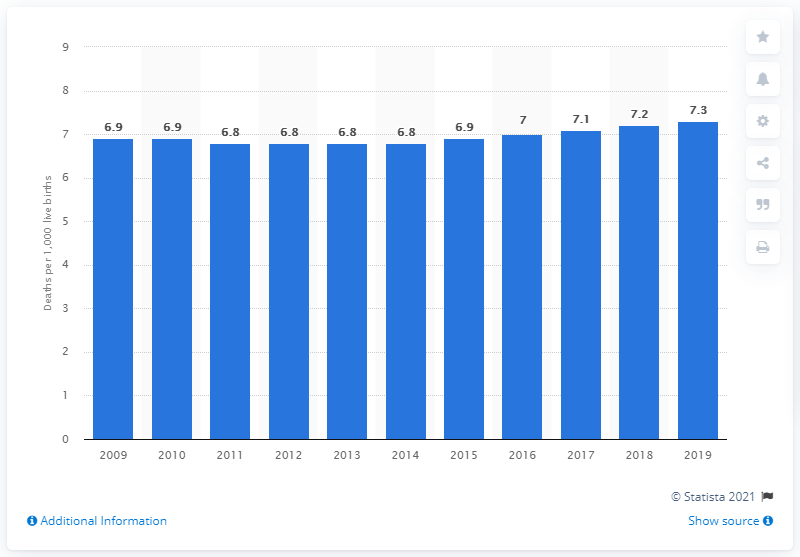Outline some significant characteristics in this image. The infant mortality rate in Malaysia in 2019 was 7.3 per 1,000 live births. 